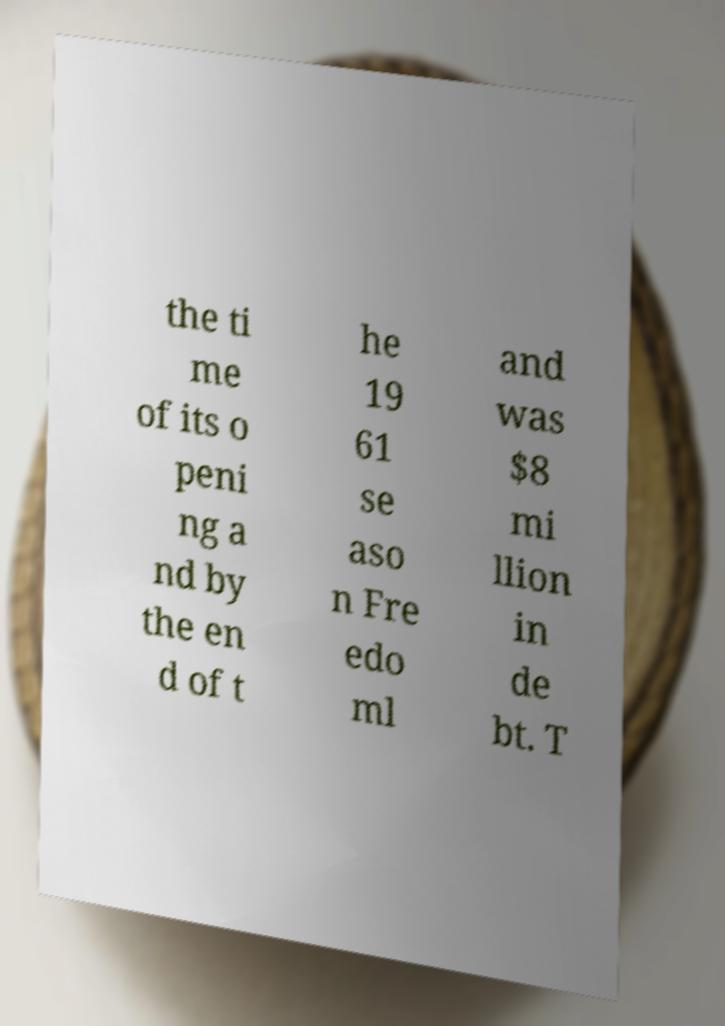Could you extract and type out the text from this image? the ti me of its o peni ng a nd by the en d of t he 19 61 se aso n Fre edo ml and was $8 mi llion in de bt. T 